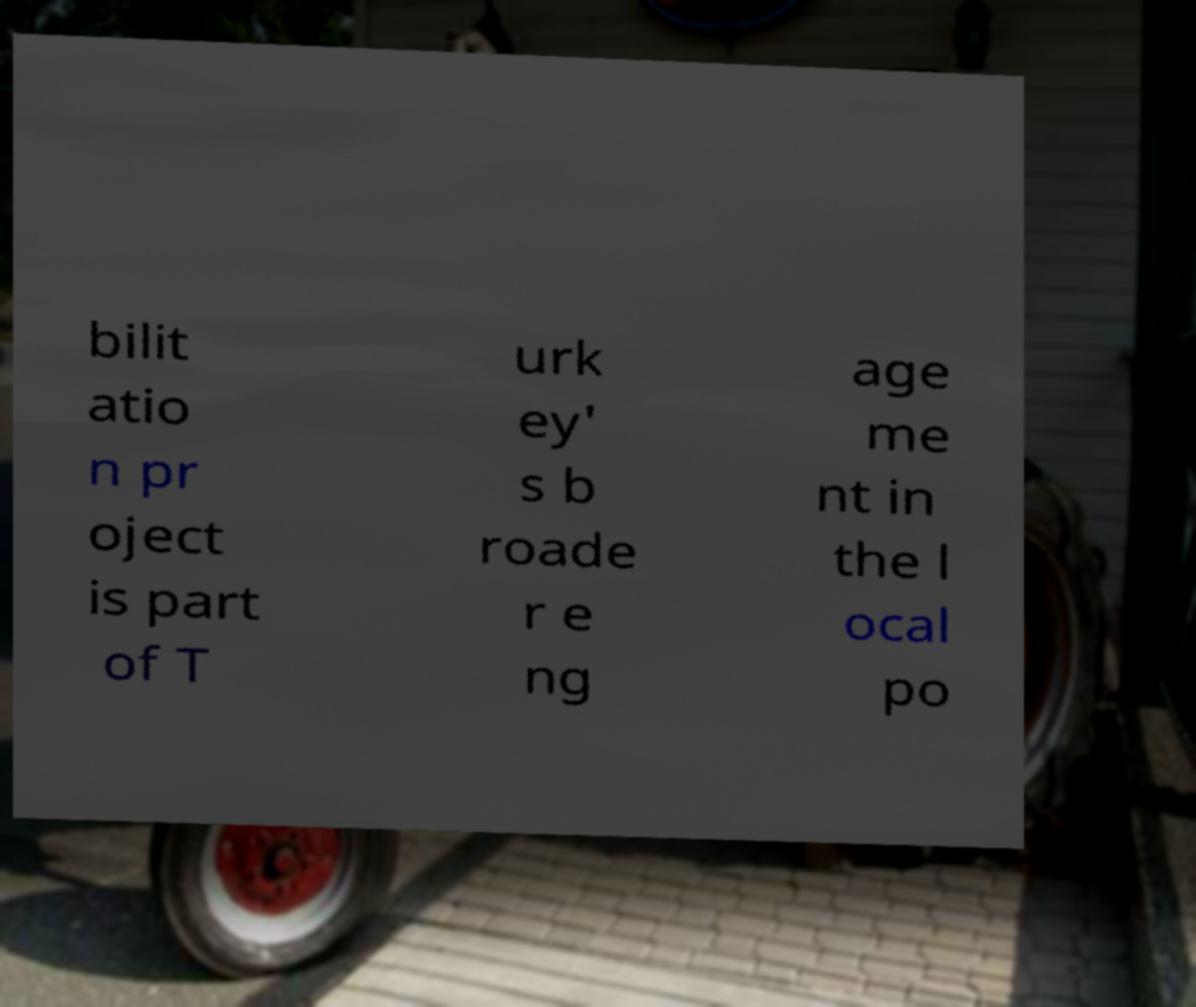There's text embedded in this image that I need extracted. Can you transcribe it verbatim? bilit atio n pr oject is part of T urk ey' s b roade r e ng age me nt in the l ocal po 